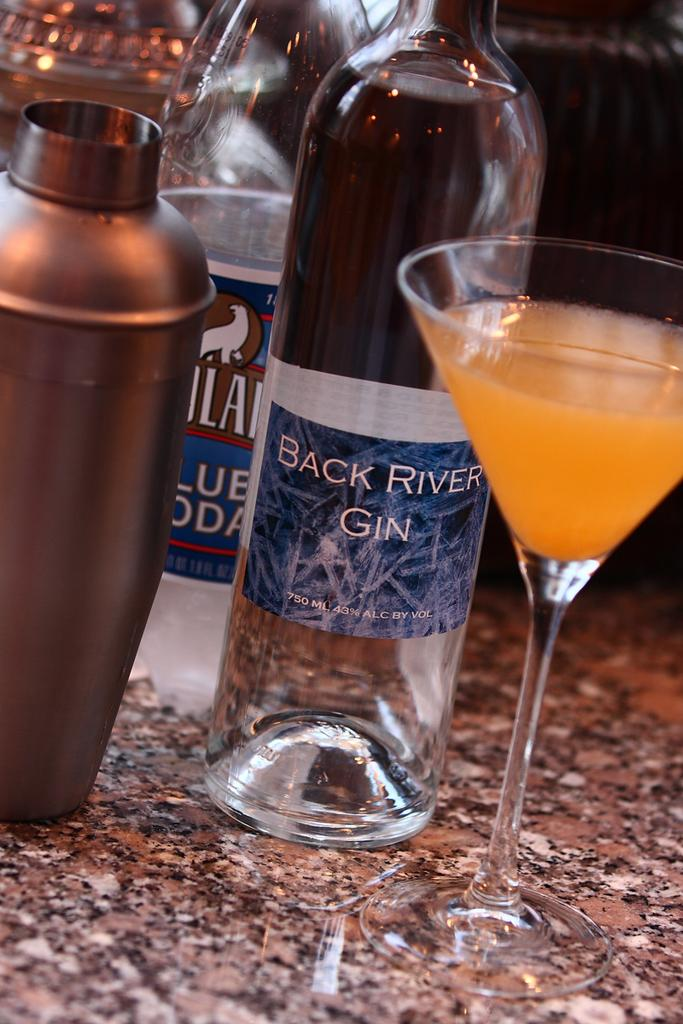How many bottles can be seen in the image? There are two bottles in the image. What type of bottles are they? The bottles are alcohol bottles. What else is present in the image besides the bottles? There is a glass in the image. What is in the glass? The glass contains an orange-colored drink. Can you describe the third bottle in the image? There is a metal bottle in the image. What verse is being recited in the image? There is no verse being recited in the image; it only contains bottles, a glass, and a drink. How many rooms are visible in the image? There is no room visible in the image, as it only shows bottles, a glass, and a drink. 